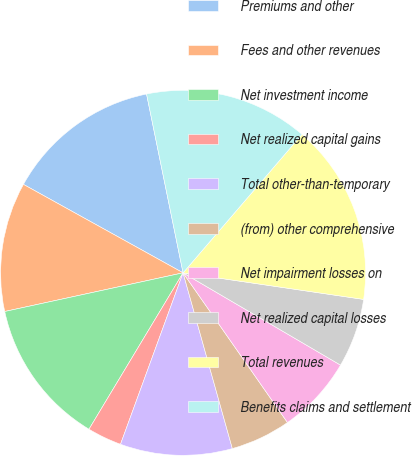Convert chart to OTSL. <chart><loc_0><loc_0><loc_500><loc_500><pie_chart><fcel>Premiums and other<fcel>Fees and other revenues<fcel>Net investment income<fcel>Net realized capital gains<fcel>Total other-than-temporary<fcel>(from) other comprehensive<fcel>Net impairment losses on<fcel>Net realized capital losses<fcel>Total revenues<fcel>Benefits claims and settlement<nl><fcel>13.74%<fcel>11.45%<fcel>12.98%<fcel>3.05%<fcel>9.92%<fcel>5.34%<fcel>6.87%<fcel>6.11%<fcel>16.03%<fcel>14.5%<nl></chart> 